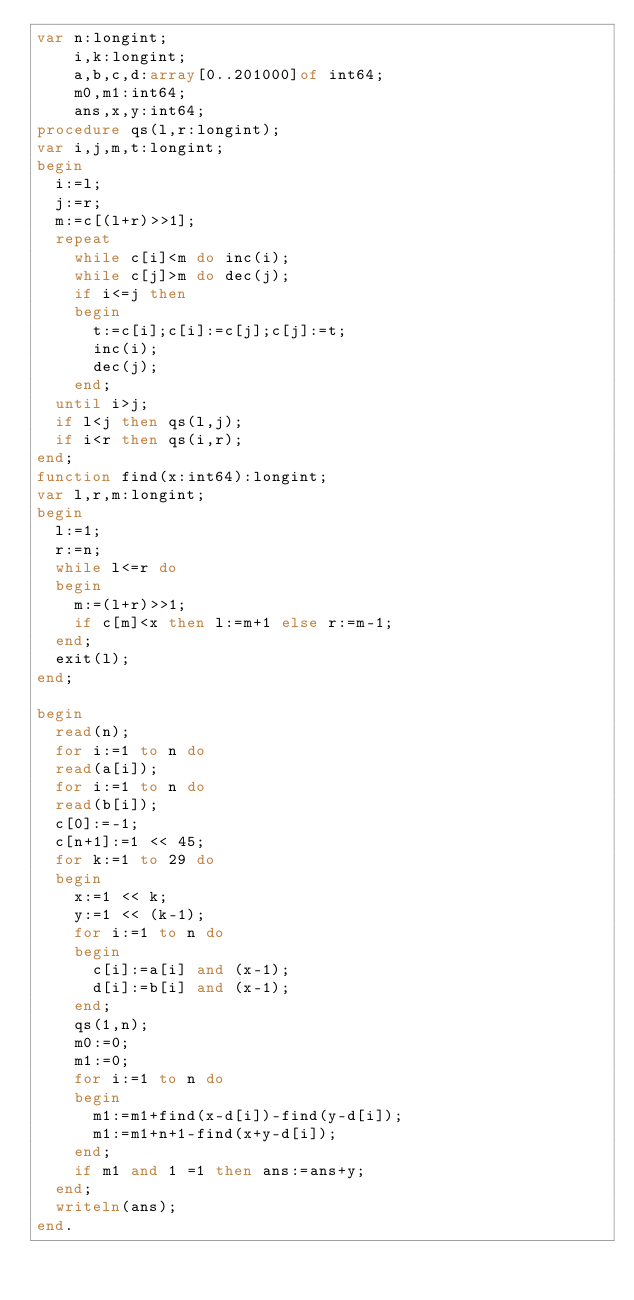Convert code to text. <code><loc_0><loc_0><loc_500><loc_500><_Pascal_>var n:longint;
    i,k:longint;
    a,b,c,d:array[0..201000]of int64;
    m0,m1:int64;
    ans,x,y:int64;
procedure qs(l,r:longint);
var i,j,m,t:longint;
begin
  i:=l;
  j:=r;
  m:=c[(l+r)>>1];
  repeat
    while c[i]<m do inc(i);
    while c[j]>m do dec(j);
    if i<=j then
    begin
      t:=c[i];c[i]:=c[j];c[j]:=t;
      inc(i);
      dec(j);
    end;
  until i>j;
  if l<j then qs(l,j);
  if i<r then qs(i,r);
end;
function find(x:int64):longint;
var l,r,m:longint;
begin
  l:=1;
  r:=n;
  while l<=r do
  begin
    m:=(l+r)>>1;
    if c[m]<x then l:=m+1 else r:=m-1;
  end;
  exit(l);
end;

begin
  read(n);
  for i:=1 to n do
  read(a[i]);
  for i:=1 to n do
  read(b[i]);
  c[0]:=-1;
  c[n+1]:=1 << 45;
  for k:=1 to 29 do
  begin
    x:=1 << k;
    y:=1 << (k-1);
    for i:=1 to n do
    begin
      c[i]:=a[i] and (x-1);
      d[i]:=b[i] and (x-1);
    end;
    qs(1,n);
    m0:=0;
    m1:=0;
    for i:=1 to n do
    begin
      m1:=m1+find(x-d[i])-find(y-d[i]);
      m1:=m1+n+1-find(x+y-d[i]);
    end;
    if m1 and 1 =1 then ans:=ans+y;
  end;
  writeln(ans);
end.

</code> 